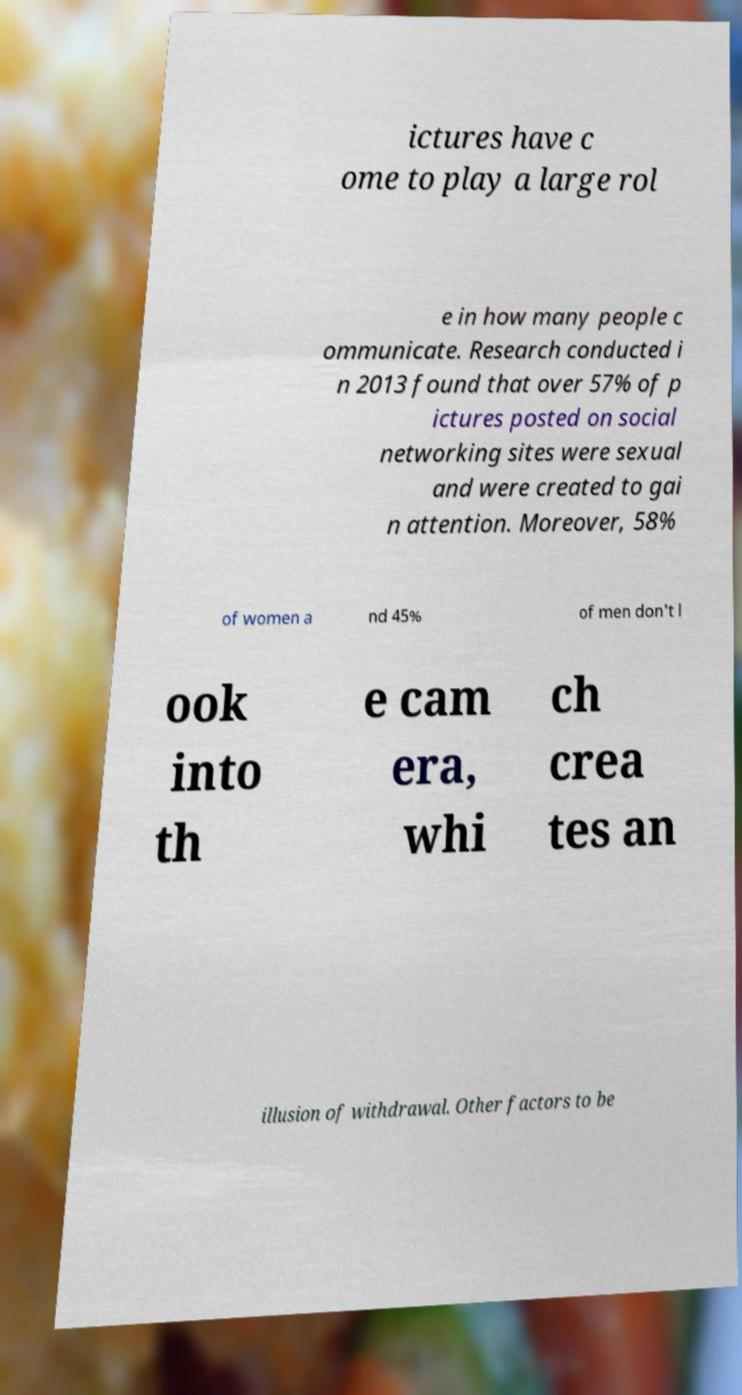Please read and relay the text visible in this image. What does it say? ictures have c ome to play a large rol e in how many people c ommunicate. Research conducted i n 2013 found that over 57% of p ictures posted on social networking sites were sexual and were created to gai n attention. Moreover, 58% of women a nd 45% of men don't l ook into th e cam era, whi ch crea tes an illusion of withdrawal. Other factors to be 